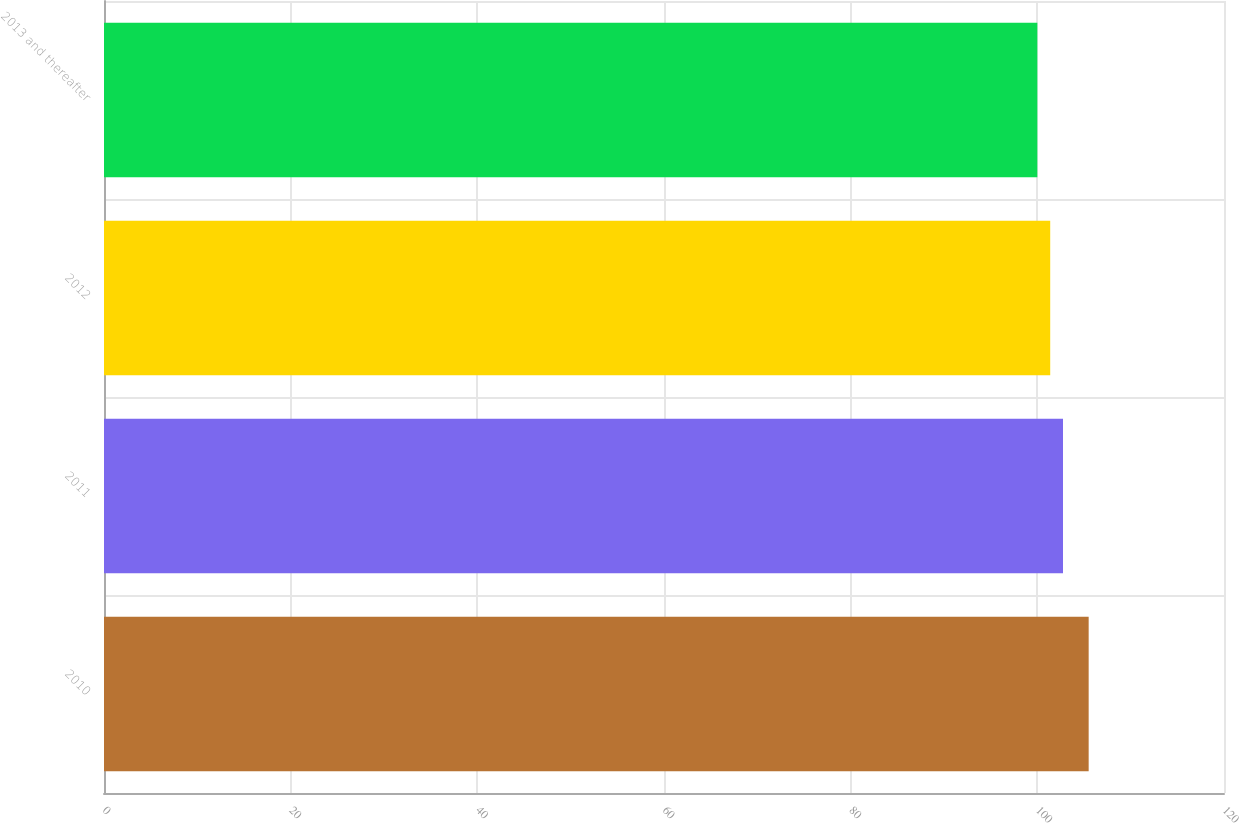Convert chart to OTSL. <chart><loc_0><loc_0><loc_500><loc_500><bar_chart><fcel>2010<fcel>2011<fcel>2012<fcel>2013 and thereafter<nl><fcel>105.5<fcel>102.75<fcel>101.38<fcel>100<nl></chart> 